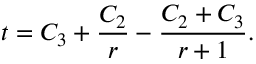<formula> <loc_0><loc_0><loc_500><loc_500>t = C _ { 3 } + \frac { C _ { 2 } } { r } - \frac { C _ { 2 } + C _ { 3 } } { r + 1 } .</formula> 